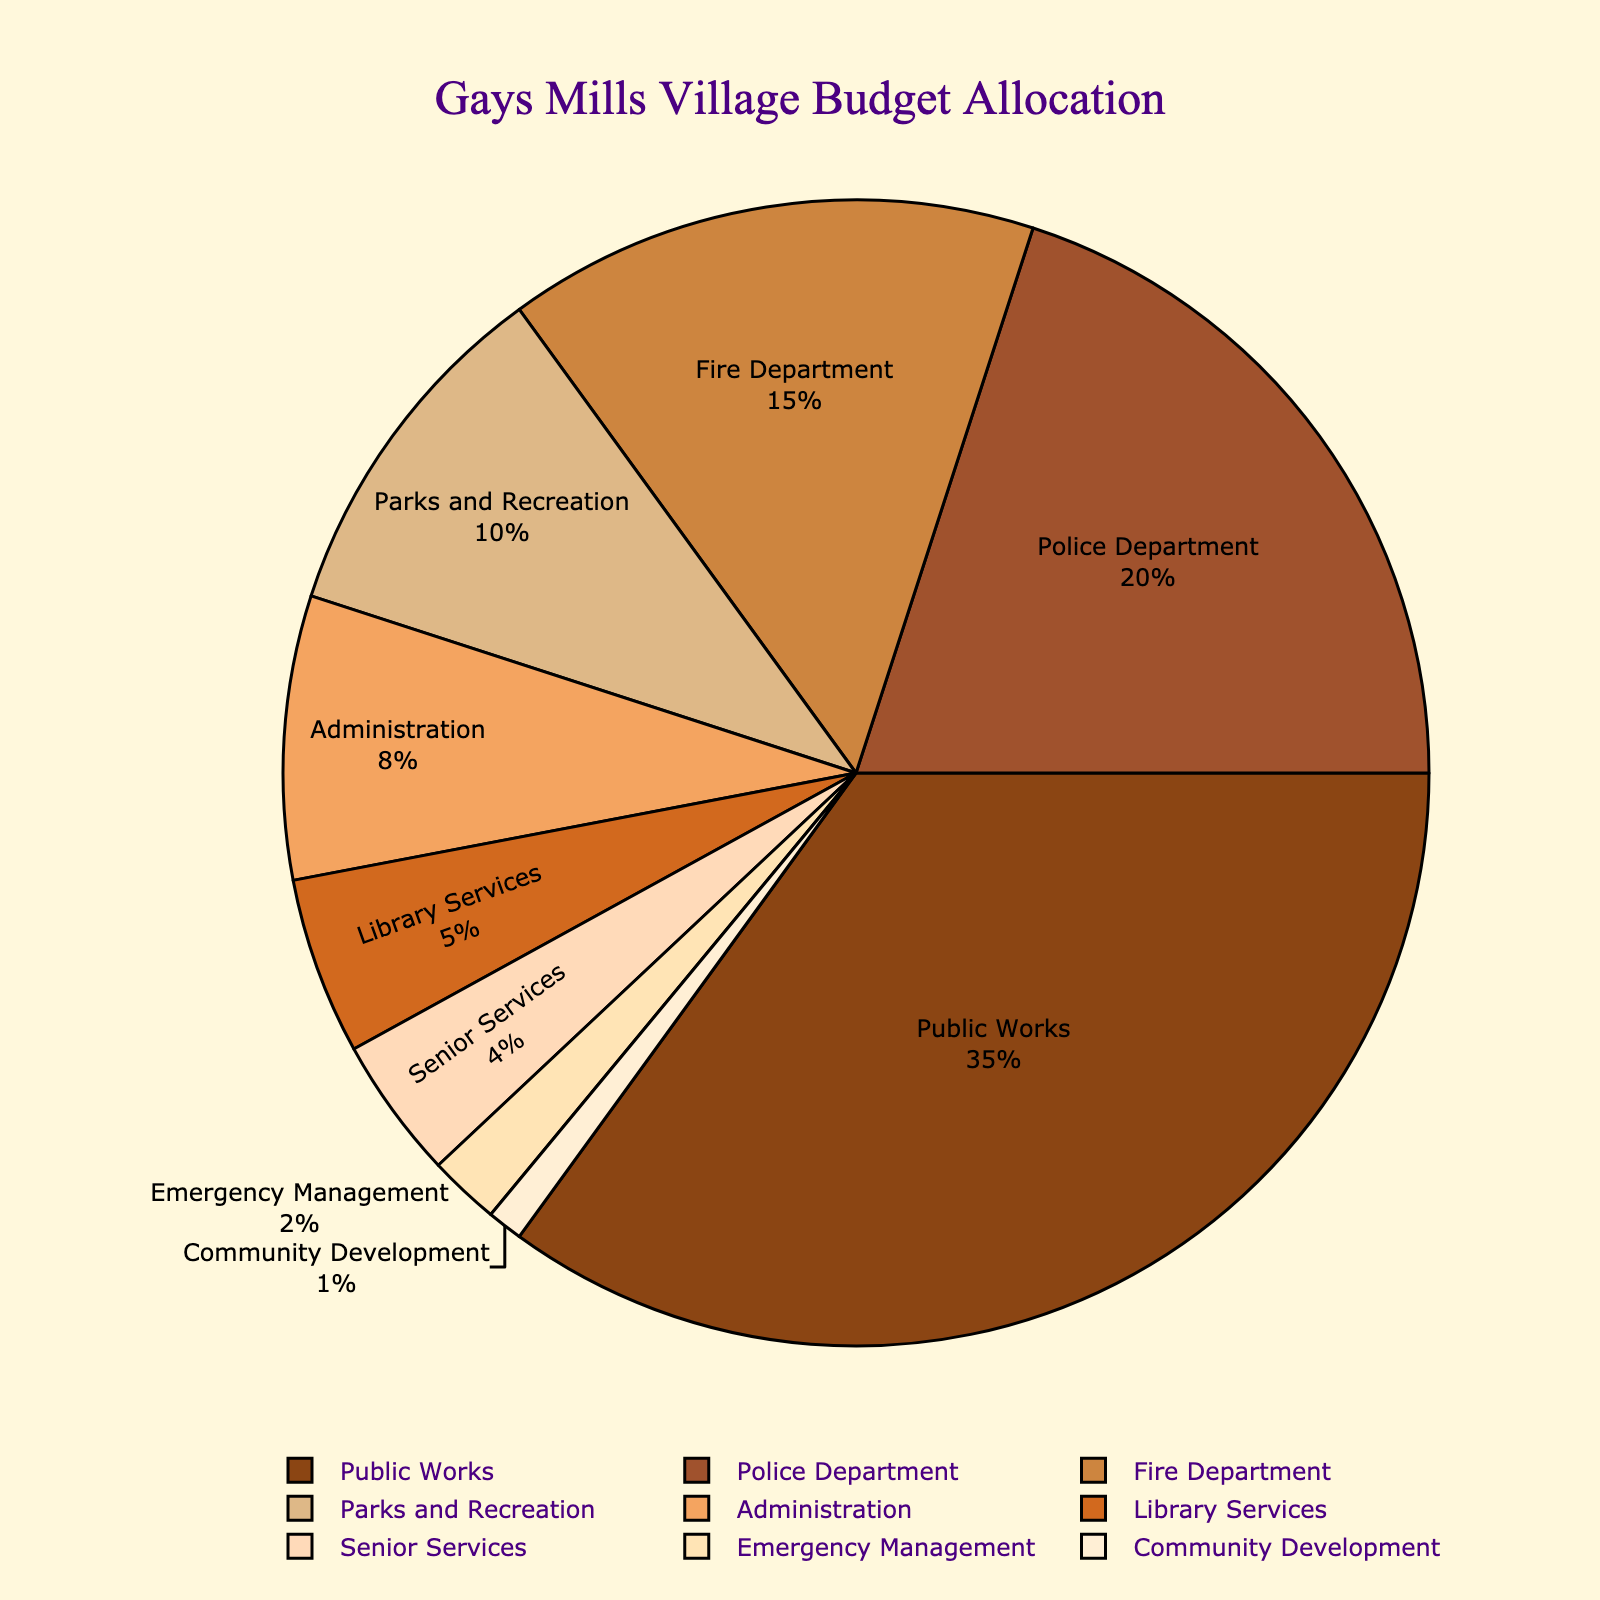What is the percentage of the budget allocated to the Public Works department? The pie chart shows each department's budget allocation as a percentage. The label for Public Works shows its percentage.
Answer: 35% Which two departments combined have the largest percentage of the budget allocation? By visually comparing the slices, we can see that Public Works (35%) and Police Department (20%) have the largest individual percentages. Combined, they represent 55% of the budget.
Answer: Public Works and Police Department What is the total percentage allocated to Emergency Management and Community Development? From the pie chart, Emergency Management has 2% and Community Development has 1%. Summing these gives 2% + 1% = 3%.
Answer: 3% How does the budget allocation for Administration compare to that for Senior Services? Administration's allocation is 8%, and Senior Services' is 4%.
Answer: Administration is double that of Senior Services If the budget were to be equally distributed between the top three departments, what would each department's allocation be? The top three departments are Public Works (35%), Police Department (20%), and Fire Department (15%). Their total is 35% + 20% + 15% = 70%. If divided equally, each would get 70% / 3 ≈ 23.33%.
Answer: 23.33% Which department has the smallest allocation and what is its percentage? By looking at the pie chart, Community Development has the smallest slice. Its label indicates 1%.
Answer: Community Development with 1% Is the budget allocation for Parks and Recreation greater than that for Library Services and Senior Services combined? Parks and Recreation’s allocation is 10%. Library Services and Senior Services together have 5% + 4% = 9%.
Answer: Yes What is the difference in budget allocation between the Fire Department and the Administration? Fire Department has a 15% allocation and Administration has 8%. The difference is 15% - 8% = 7%.
Answer: 7% Rank the departments from highest to lowest percentage allocation. The labels show the percentage allocations. By ordering them: Public Works (35%), Police Department (20%), Fire Department (15%), Parks and Recreation (10%), Administration (8%), Library Services (5%), Senior Services (4%), Emergency Management (2%), Community Development (1%).
Answer: Public Works, Police Department, Fire Department, Parks and Recreation, Administration, Library Services, Senior Services, Emergency Management, Community Development 